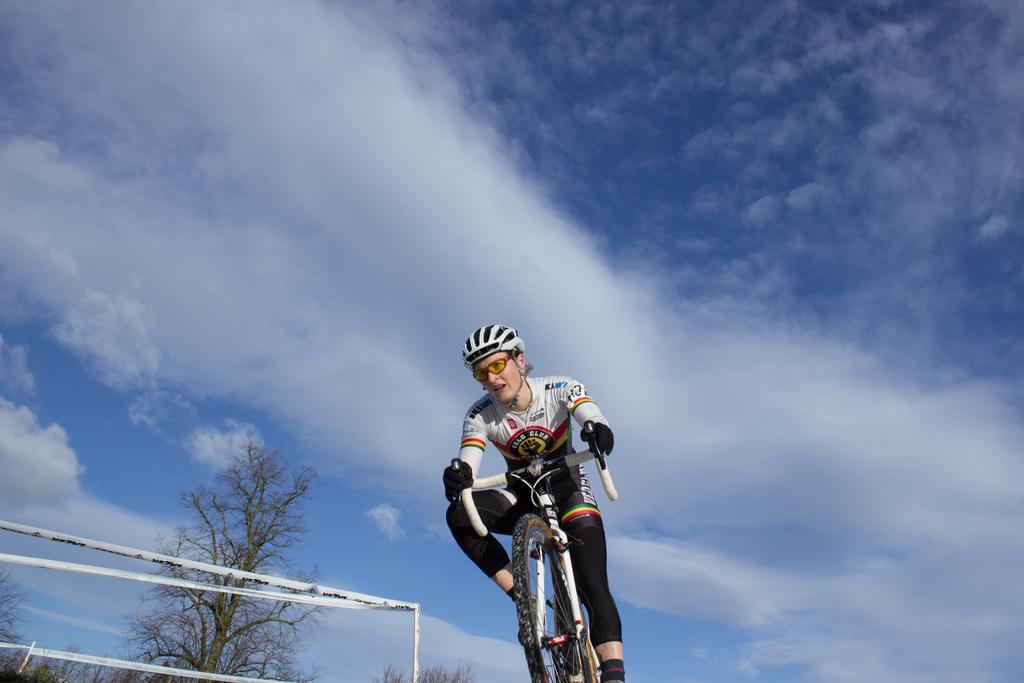Could you give a brief overview of what you see in this image? In this picture I can see a man in front, who is on the cycle and I see that he is wearing a jersey and a helmet on his head. In the middle of this picture I can see few trees and I can see the barricade tapes. In the background I can see the sky. 